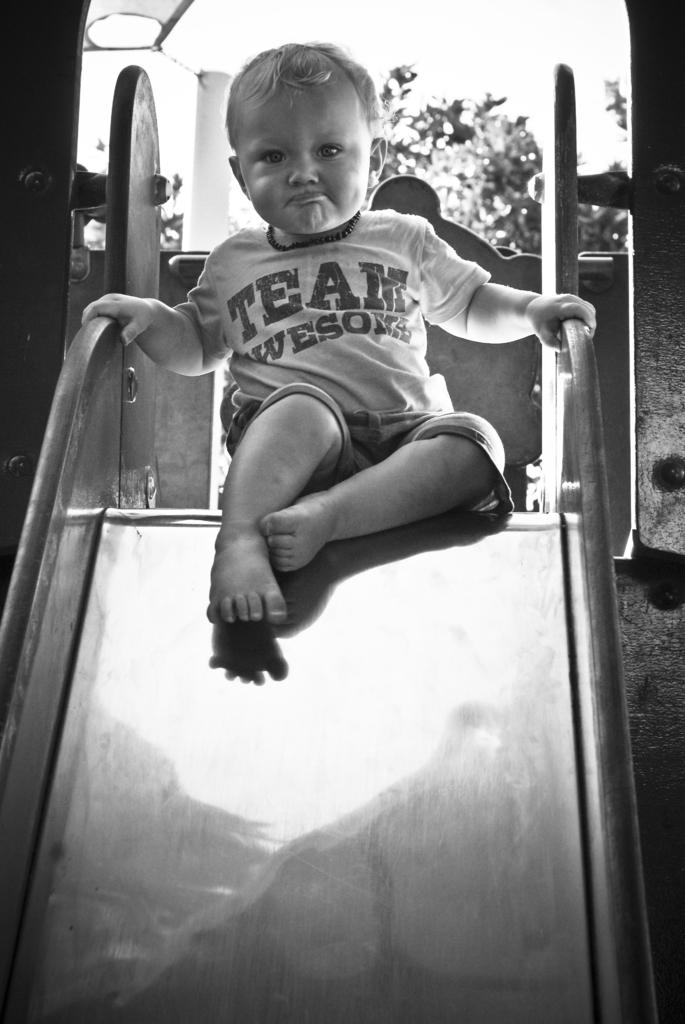What is the color scheme of the image? The image is black and white. What is the boy doing in the image? The boy is sitting on a slider. What can be seen in the background of the image? There are trees and a pole in the background of the image. What type of drink is the boy holding in the image? There is no drink visible in the image; the boy is sitting on a slider. 